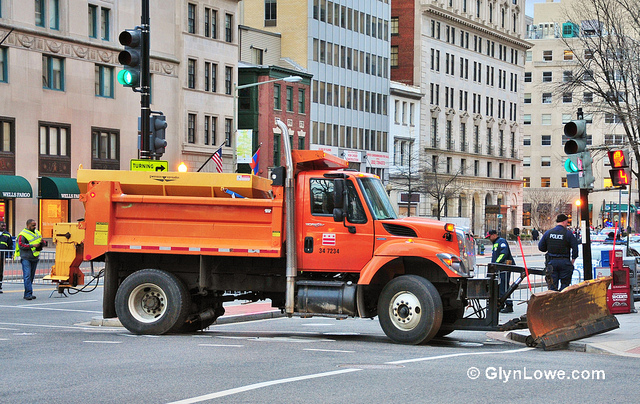What kind of work do you think the orange truck is being used for? The orange truck in the image appears to be a municipal utility vehicle, likely used for road maintenance purposes such as snow plowing or clearing debris from the streets. The presence of the plow blade attached to the front of the truck suggests that it may be involved in removing snow or other obstructions from the road to ensure safe driving conditions. 